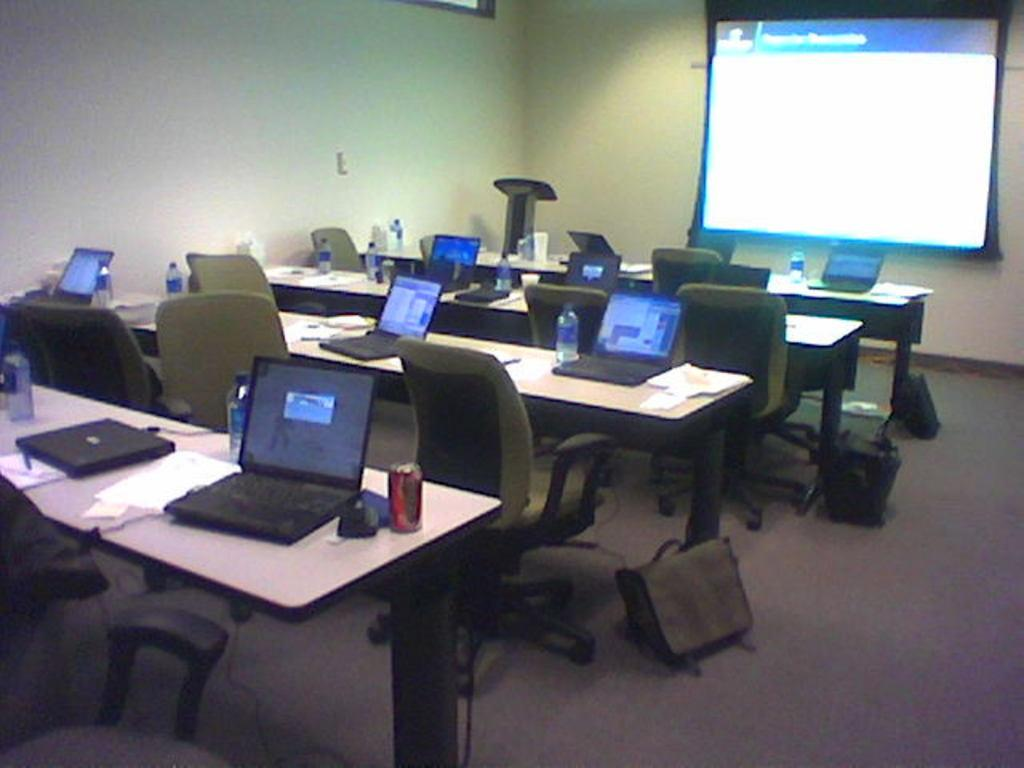What is the purpose of the empty chairs in front of the tables? The empty chairs are likely meant for people to sit and use the laptops on the tables. What can be found on the tables in the image? The tables have laptops, papers, and water bottles on them. What is being projected in front of the tables? There is a projected image in front of the tables. What is the coach's opinion on the projected image? There is no coach or opinion present in the image; it only shows empty chairs, tables, laptops, papers, water bottles, and a projected image. 